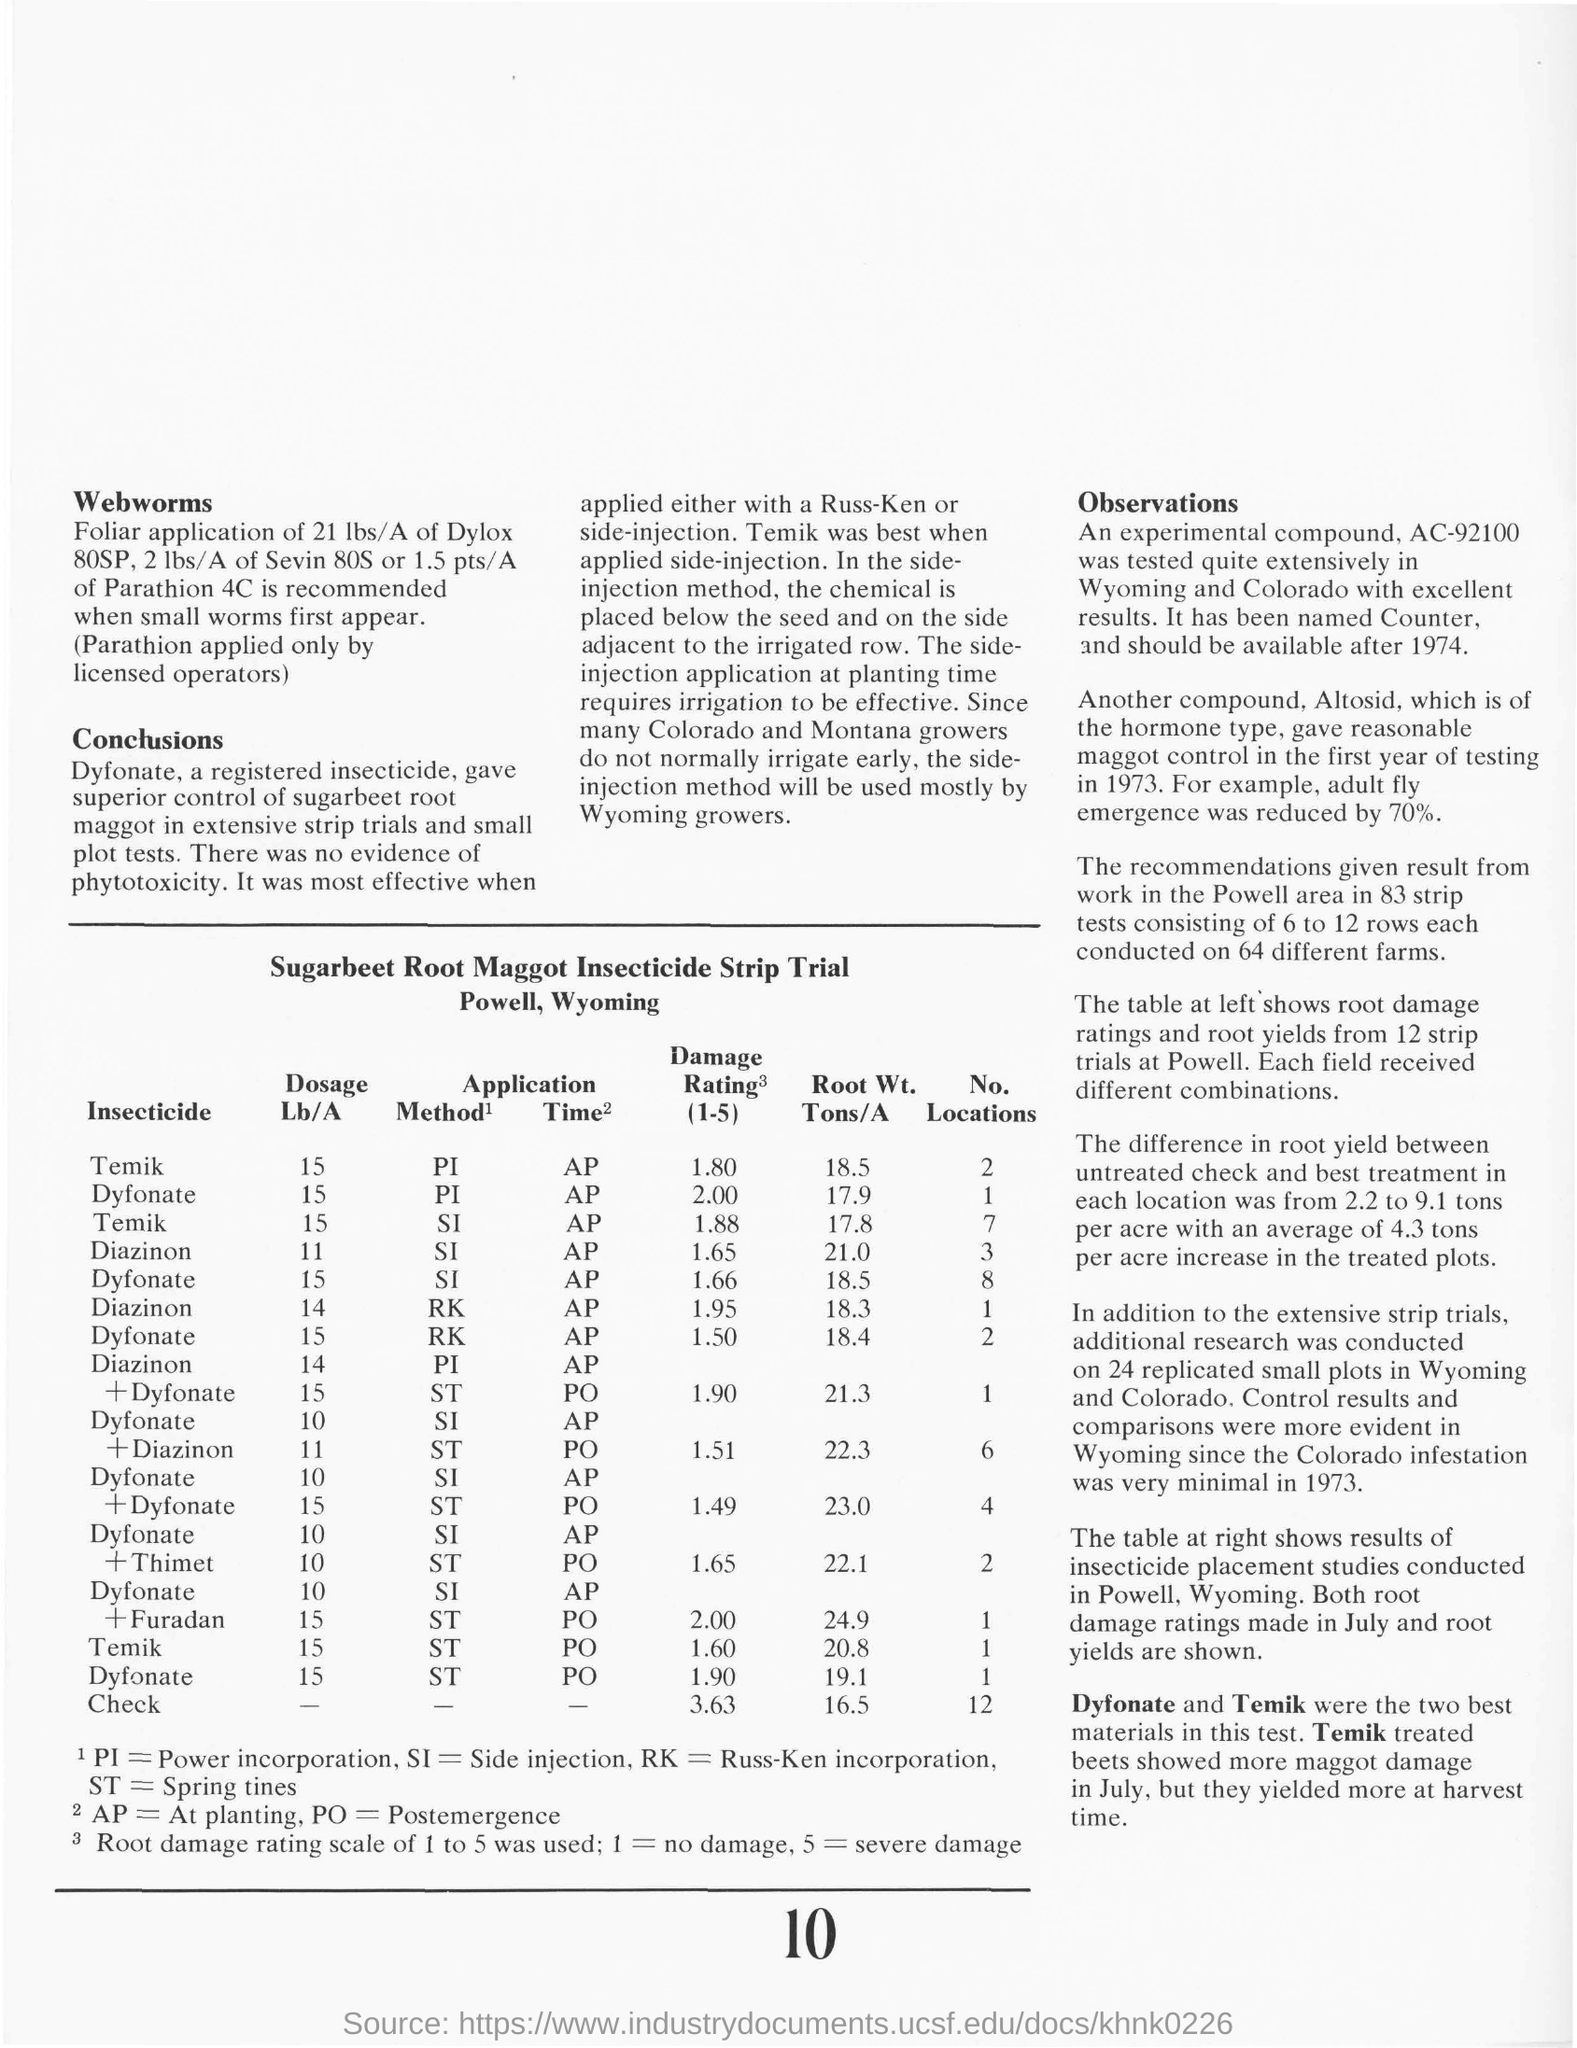What is the dosage of Temik used for SI Method at Planting time?
Ensure brevity in your answer.  15. What is the dosage of Dyfonate used for PI Method at Planting time?
Offer a terse response. 15 Lb/A. Data of which trial is given in the table?
Provide a succinct answer. Sugarbeet Root Maggot Insecticide Strip Trial. What are the two best insecticides used in the test?
Make the answer very short. Dyfonate and Temik. What is the damage rating observed for 15 Lb/A dose of Temik for PI method ?
Offer a terse response. 1.80. 